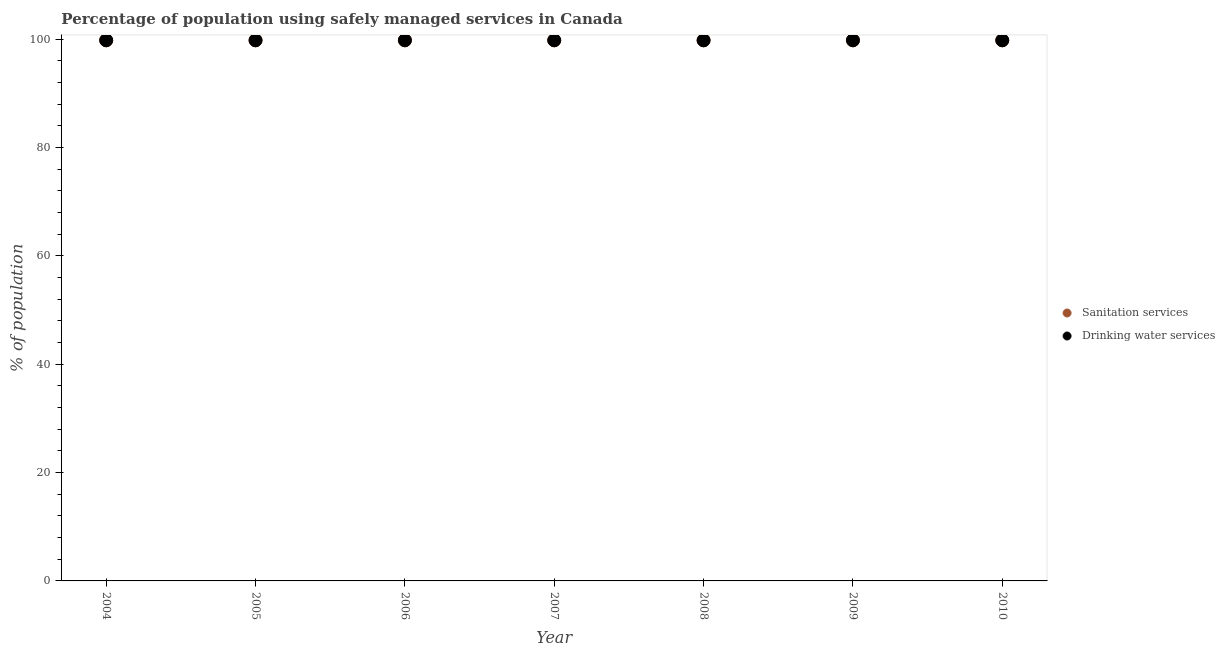Is the number of dotlines equal to the number of legend labels?
Offer a terse response. Yes. What is the percentage of population who used drinking water services in 2004?
Offer a terse response. 99.8. Across all years, what is the maximum percentage of population who used drinking water services?
Offer a terse response. 99.8. Across all years, what is the minimum percentage of population who used drinking water services?
Ensure brevity in your answer.  99.8. In which year was the percentage of population who used drinking water services minimum?
Provide a short and direct response. 2004. What is the total percentage of population who used drinking water services in the graph?
Offer a terse response. 698.6. What is the difference between the percentage of population who used sanitation services in 2006 and that in 2007?
Your response must be concise. 0. What is the average percentage of population who used sanitation services per year?
Your answer should be compact. 99.8. In the year 2010, what is the difference between the percentage of population who used drinking water services and percentage of population who used sanitation services?
Your response must be concise. 0. In how many years, is the percentage of population who used sanitation services greater than 4 %?
Make the answer very short. 7. What is the difference between the highest and the second highest percentage of population who used drinking water services?
Offer a terse response. 0. In how many years, is the percentage of population who used sanitation services greater than the average percentage of population who used sanitation services taken over all years?
Ensure brevity in your answer.  7. Does the percentage of population who used sanitation services monotonically increase over the years?
Provide a short and direct response. No. How many dotlines are there?
Your response must be concise. 2. Are the values on the major ticks of Y-axis written in scientific E-notation?
Offer a terse response. No. How are the legend labels stacked?
Keep it short and to the point. Vertical. What is the title of the graph?
Offer a very short reply. Percentage of population using safely managed services in Canada. What is the label or title of the X-axis?
Provide a short and direct response. Year. What is the label or title of the Y-axis?
Give a very brief answer. % of population. What is the % of population in Sanitation services in 2004?
Your response must be concise. 99.8. What is the % of population in Drinking water services in 2004?
Make the answer very short. 99.8. What is the % of population of Sanitation services in 2005?
Give a very brief answer. 99.8. What is the % of population of Drinking water services in 2005?
Keep it short and to the point. 99.8. What is the % of population of Sanitation services in 2006?
Provide a short and direct response. 99.8. What is the % of population of Drinking water services in 2006?
Your answer should be compact. 99.8. What is the % of population in Sanitation services in 2007?
Make the answer very short. 99.8. What is the % of population in Drinking water services in 2007?
Your answer should be compact. 99.8. What is the % of population of Sanitation services in 2008?
Ensure brevity in your answer.  99.8. What is the % of population of Drinking water services in 2008?
Keep it short and to the point. 99.8. What is the % of population of Sanitation services in 2009?
Your response must be concise. 99.8. What is the % of population in Drinking water services in 2009?
Offer a terse response. 99.8. What is the % of population in Sanitation services in 2010?
Your response must be concise. 99.8. What is the % of population in Drinking water services in 2010?
Offer a very short reply. 99.8. Across all years, what is the maximum % of population in Sanitation services?
Provide a short and direct response. 99.8. Across all years, what is the maximum % of population in Drinking water services?
Make the answer very short. 99.8. Across all years, what is the minimum % of population in Sanitation services?
Provide a succinct answer. 99.8. Across all years, what is the minimum % of population of Drinking water services?
Your answer should be very brief. 99.8. What is the total % of population in Sanitation services in the graph?
Ensure brevity in your answer.  698.6. What is the total % of population in Drinking water services in the graph?
Provide a short and direct response. 698.6. What is the difference between the % of population in Sanitation services in 2004 and that in 2005?
Give a very brief answer. 0. What is the difference between the % of population in Drinking water services in 2004 and that in 2005?
Your answer should be compact. 0. What is the difference between the % of population of Sanitation services in 2004 and that in 2006?
Offer a very short reply. 0. What is the difference between the % of population in Drinking water services in 2004 and that in 2006?
Your answer should be very brief. 0. What is the difference between the % of population of Sanitation services in 2004 and that in 2007?
Provide a short and direct response. 0. What is the difference between the % of population of Drinking water services in 2004 and that in 2007?
Provide a succinct answer. 0. What is the difference between the % of population of Sanitation services in 2004 and that in 2008?
Your response must be concise. 0. What is the difference between the % of population of Drinking water services in 2004 and that in 2008?
Keep it short and to the point. 0. What is the difference between the % of population of Sanitation services in 2004 and that in 2010?
Make the answer very short. 0. What is the difference between the % of population of Sanitation services in 2005 and that in 2006?
Your answer should be compact. 0. What is the difference between the % of population of Drinking water services in 2005 and that in 2006?
Ensure brevity in your answer.  0. What is the difference between the % of population of Drinking water services in 2005 and that in 2010?
Offer a very short reply. 0. What is the difference between the % of population of Sanitation services in 2006 and that in 2007?
Make the answer very short. 0. What is the difference between the % of population of Sanitation services in 2006 and that in 2008?
Your response must be concise. 0. What is the difference between the % of population of Sanitation services in 2006 and that in 2009?
Offer a very short reply. 0. What is the difference between the % of population in Sanitation services in 2006 and that in 2010?
Offer a terse response. 0. What is the difference between the % of population in Drinking water services in 2006 and that in 2010?
Keep it short and to the point. 0. What is the difference between the % of population in Sanitation services in 2007 and that in 2010?
Offer a terse response. 0. What is the difference between the % of population of Drinking water services in 2008 and that in 2009?
Offer a terse response. 0. What is the difference between the % of population in Sanitation services in 2009 and that in 2010?
Your answer should be compact. 0. What is the difference between the % of population of Drinking water services in 2009 and that in 2010?
Offer a terse response. 0. What is the difference between the % of population in Sanitation services in 2004 and the % of population in Drinking water services in 2007?
Provide a short and direct response. 0. What is the difference between the % of population of Sanitation services in 2004 and the % of population of Drinking water services in 2008?
Keep it short and to the point. 0. What is the difference between the % of population of Sanitation services in 2004 and the % of population of Drinking water services in 2010?
Give a very brief answer. 0. What is the difference between the % of population in Sanitation services in 2005 and the % of population in Drinking water services in 2007?
Provide a short and direct response. 0. What is the difference between the % of population in Sanitation services in 2006 and the % of population in Drinking water services in 2007?
Your answer should be compact. 0. What is the difference between the % of population in Sanitation services in 2006 and the % of population in Drinking water services in 2008?
Offer a terse response. 0. What is the difference between the % of population in Sanitation services in 2007 and the % of population in Drinking water services in 2008?
Give a very brief answer. 0. What is the difference between the % of population of Sanitation services in 2008 and the % of population of Drinking water services in 2009?
Ensure brevity in your answer.  0. What is the difference between the % of population in Sanitation services in 2009 and the % of population in Drinking water services in 2010?
Keep it short and to the point. 0. What is the average % of population of Sanitation services per year?
Offer a terse response. 99.8. What is the average % of population in Drinking water services per year?
Ensure brevity in your answer.  99.8. In the year 2005, what is the difference between the % of population of Sanitation services and % of population of Drinking water services?
Keep it short and to the point. 0. In the year 2006, what is the difference between the % of population in Sanitation services and % of population in Drinking water services?
Your answer should be very brief. 0. In the year 2007, what is the difference between the % of population in Sanitation services and % of population in Drinking water services?
Your response must be concise. 0. In the year 2009, what is the difference between the % of population of Sanitation services and % of population of Drinking water services?
Provide a short and direct response. 0. In the year 2010, what is the difference between the % of population of Sanitation services and % of population of Drinking water services?
Provide a succinct answer. 0. What is the ratio of the % of population in Sanitation services in 2004 to that in 2005?
Your answer should be compact. 1. What is the ratio of the % of population in Drinking water services in 2004 to that in 2005?
Your answer should be compact. 1. What is the ratio of the % of population in Drinking water services in 2004 to that in 2006?
Make the answer very short. 1. What is the ratio of the % of population in Drinking water services in 2004 to that in 2008?
Your answer should be very brief. 1. What is the ratio of the % of population in Drinking water services in 2004 to that in 2009?
Provide a short and direct response. 1. What is the ratio of the % of population in Sanitation services in 2004 to that in 2010?
Provide a succinct answer. 1. What is the ratio of the % of population of Drinking water services in 2005 to that in 2006?
Your answer should be compact. 1. What is the ratio of the % of population of Sanitation services in 2005 to that in 2007?
Provide a short and direct response. 1. What is the ratio of the % of population of Drinking water services in 2005 to that in 2008?
Give a very brief answer. 1. What is the ratio of the % of population of Drinking water services in 2005 to that in 2009?
Offer a very short reply. 1. What is the ratio of the % of population of Sanitation services in 2005 to that in 2010?
Keep it short and to the point. 1. What is the ratio of the % of population in Drinking water services in 2005 to that in 2010?
Offer a very short reply. 1. What is the ratio of the % of population of Drinking water services in 2006 to that in 2007?
Offer a terse response. 1. What is the ratio of the % of population in Sanitation services in 2006 to that in 2008?
Your response must be concise. 1. What is the ratio of the % of population in Drinking water services in 2006 to that in 2008?
Provide a succinct answer. 1. What is the ratio of the % of population in Drinking water services in 2006 to that in 2010?
Give a very brief answer. 1. What is the ratio of the % of population of Sanitation services in 2007 to that in 2008?
Provide a short and direct response. 1. What is the ratio of the % of population in Sanitation services in 2007 to that in 2009?
Make the answer very short. 1. What is the ratio of the % of population in Drinking water services in 2007 to that in 2009?
Offer a very short reply. 1. What is the ratio of the % of population of Sanitation services in 2007 to that in 2010?
Provide a short and direct response. 1. What is the ratio of the % of population of Drinking water services in 2007 to that in 2010?
Offer a very short reply. 1. What is the ratio of the % of population of Sanitation services in 2008 to that in 2009?
Provide a short and direct response. 1. What is the ratio of the % of population of Drinking water services in 2008 to that in 2009?
Keep it short and to the point. 1. What is the ratio of the % of population of Sanitation services in 2008 to that in 2010?
Your answer should be compact. 1. What is the ratio of the % of population in Sanitation services in 2009 to that in 2010?
Your response must be concise. 1. What is the difference between the highest and the second highest % of population of Sanitation services?
Offer a very short reply. 0. What is the difference between the highest and the lowest % of population of Sanitation services?
Your answer should be very brief. 0. What is the difference between the highest and the lowest % of population of Drinking water services?
Provide a short and direct response. 0. 